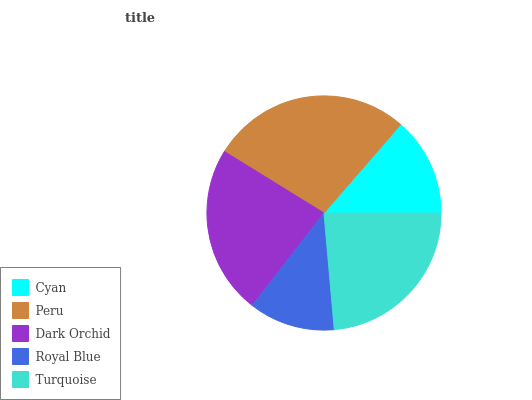Is Royal Blue the minimum?
Answer yes or no. Yes. Is Peru the maximum?
Answer yes or no. Yes. Is Dark Orchid the minimum?
Answer yes or no. No. Is Dark Orchid the maximum?
Answer yes or no. No. Is Peru greater than Dark Orchid?
Answer yes or no. Yes. Is Dark Orchid less than Peru?
Answer yes or no. Yes. Is Dark Orchid greater than Peru?
Answer yes or no. No. Is Peru less than Dark Orchid?
Answer yes or no. No. Is Dark Orchid the high median?
Answer yes or no. Yes. Is Dark Orchid the low median?
Answer yes or no. Yes. Is Peru the high median?
Answer yes or no. No. Is Turquoise the low median?
Answer yes or no. No. 